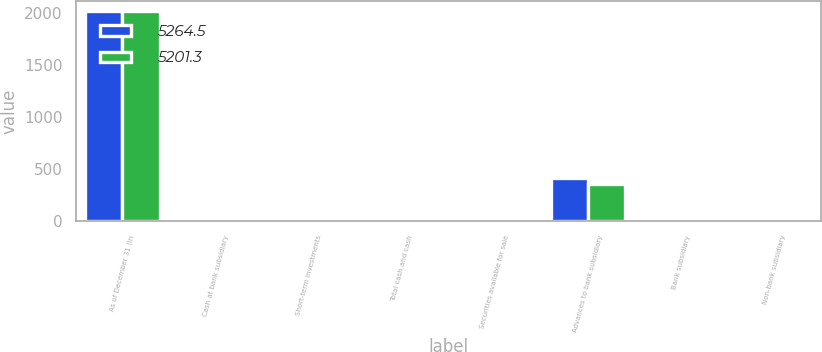Convert chart to OTSL. <chart><loc_0><loc_0><loc_500><loc_500><stacked_bar_chart><ecel><fcel>As of December 31 (in<fcel>Cash at bank subsidiary<fcel>Short-term investments<fcel>Total cash and cash<fcel>Securities available for sale<fcel>Advances to bank subsidiary<fcel>Bank subsidiary<fcel>Non-bank subsidiary<nl><fcel>5264.5<fcel>2014<fcel>3.1<fcel>1.2<fcel>4.3<fcel>0.2<fcel>410<fcel>3.7<fcel>0.4<nl><fcel>5201.3<fcel>2013<fcel>20.2<fcel>1.7<fcel>21.9<fcel>2.7<fcel>353<fcel>3.7<fcel>1.5<nl></chart> 